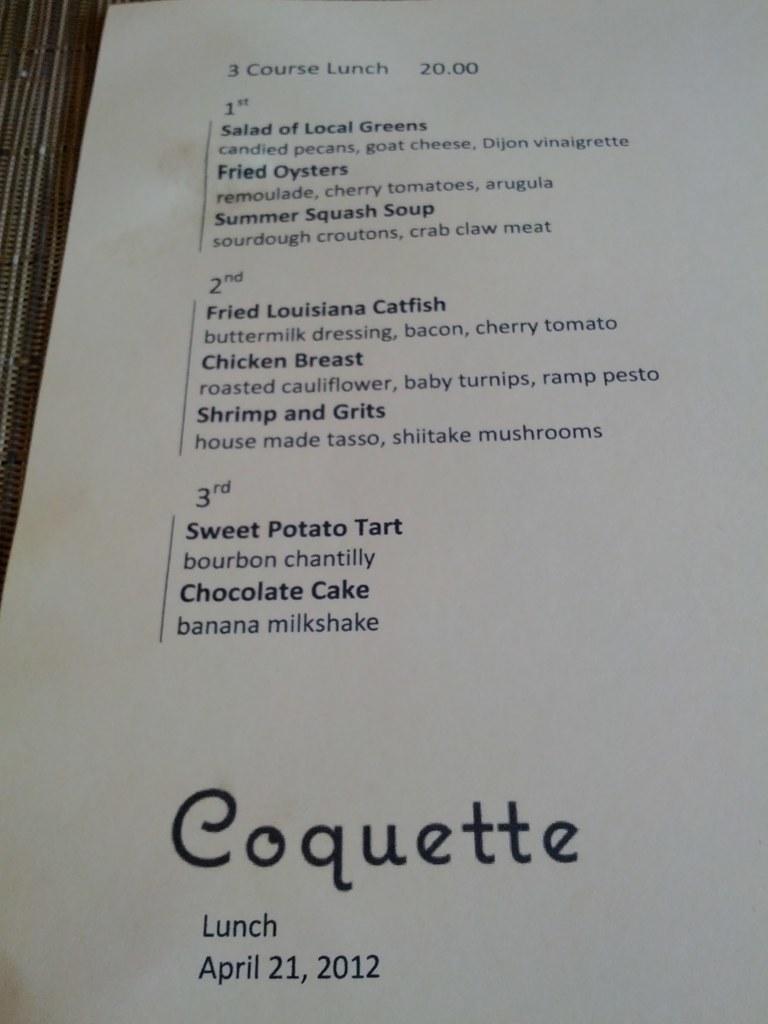What is the date on the bottom of the menu?
Give a very brief answer. April 21, 2012. 